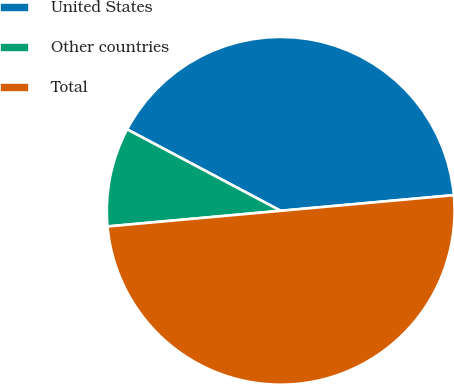Convert chart to OTSL. <chart><loc_0><loc_0><loc_500><loc_500><pie_chart><fcel>United States<fcel>Other countries<fcel>Total<nl><fcel>40.8%<fcel>9.2%<fcel>50.0%<nl></chart> 